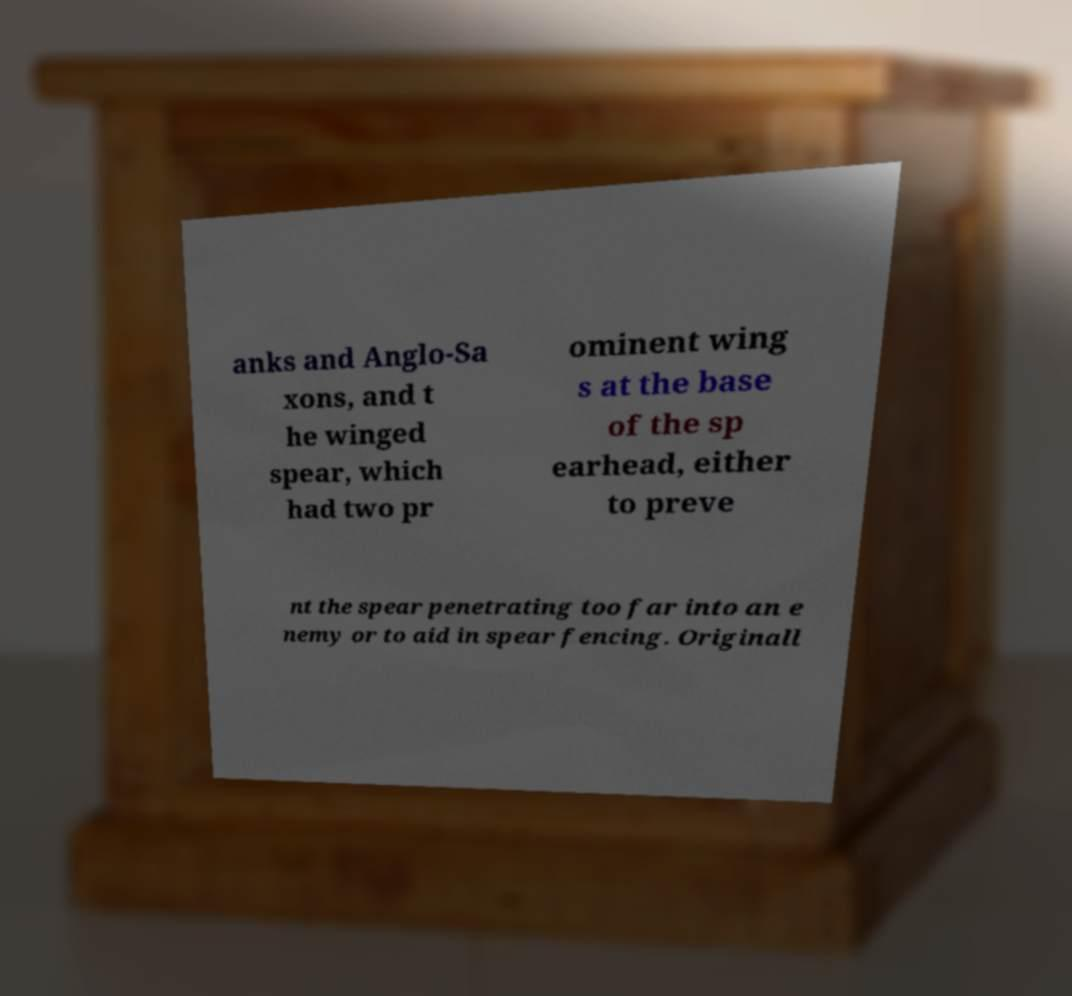I need the written content from this picture converted into text. Can you do that? anks and Anglo-Sa xons, and t he winged spear, which had two pr ominent wing s at the base of the sp earhead, either to preve nt the spear penetrating too far into an e nemy or to aid in spear fencing. Originall 